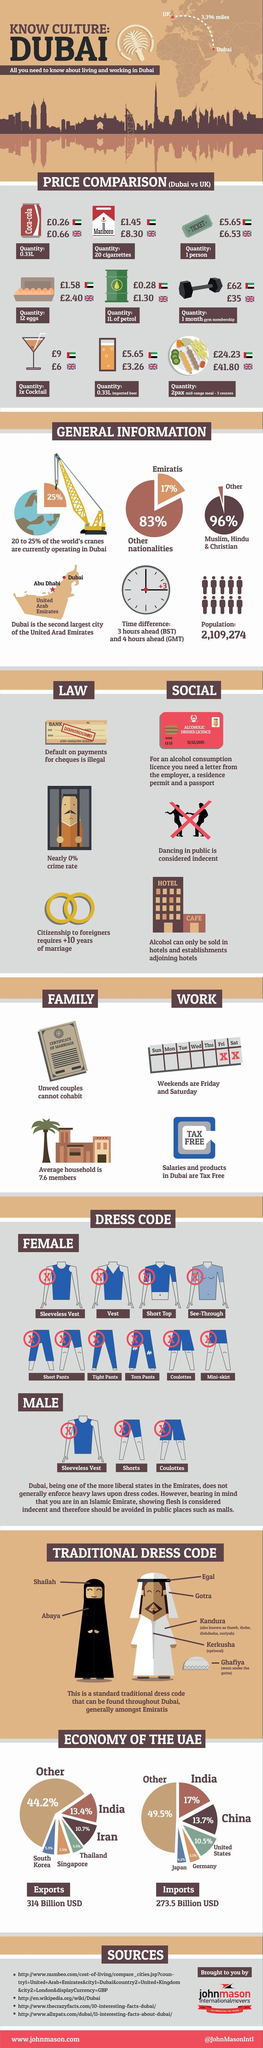What is the difference in price of 12 eggs in Dubai and UK in pounds?
Answer the question with a short phrase. 0.82 What is the difference in price of 20 cigarettes in Dubai and UK in pounds? 6.85 what is the percentage of exports to India and Iran combined? 24.1 Which type of dresses are not allowed for men in Dubai? sleeveless vest, shorts, coulottes how many given products are more expensive in UK than Dubai? 6 In which county Coca-Cola is more expensive - UK or Dubai? UK what is the percentage of imports of Japan and Germany combined? 9.3 what are the traditional dress code for women? shailah, abaya In which county gym membership is more expensive - UK or Dubai? Dubai In which county beer is more expensive - UK or Dubai? Dubai what is the percentage of exports to Thailand and Singapore combined? 11 what is the percentage of imports of India and China combined? 30.7 what is the percentage of imports of US and Germany combined? 15.6% What is the difference in price of 1 liter petrol in Dubai and UK in pounds? 1.02 how many given products are less expensive in UK than Dubai? 3 